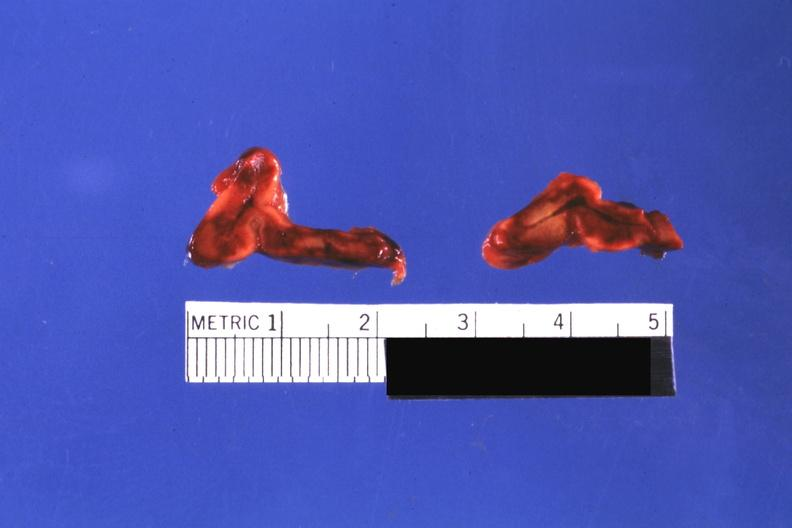what is present?
Answer the question using a single word or phrase. Endocrine 